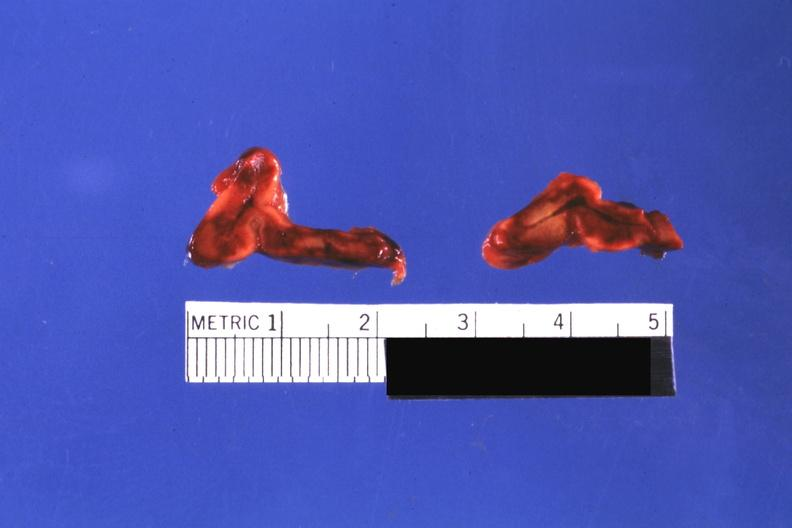what is present?
Answer the question using a single word or phrase. Endocrine 